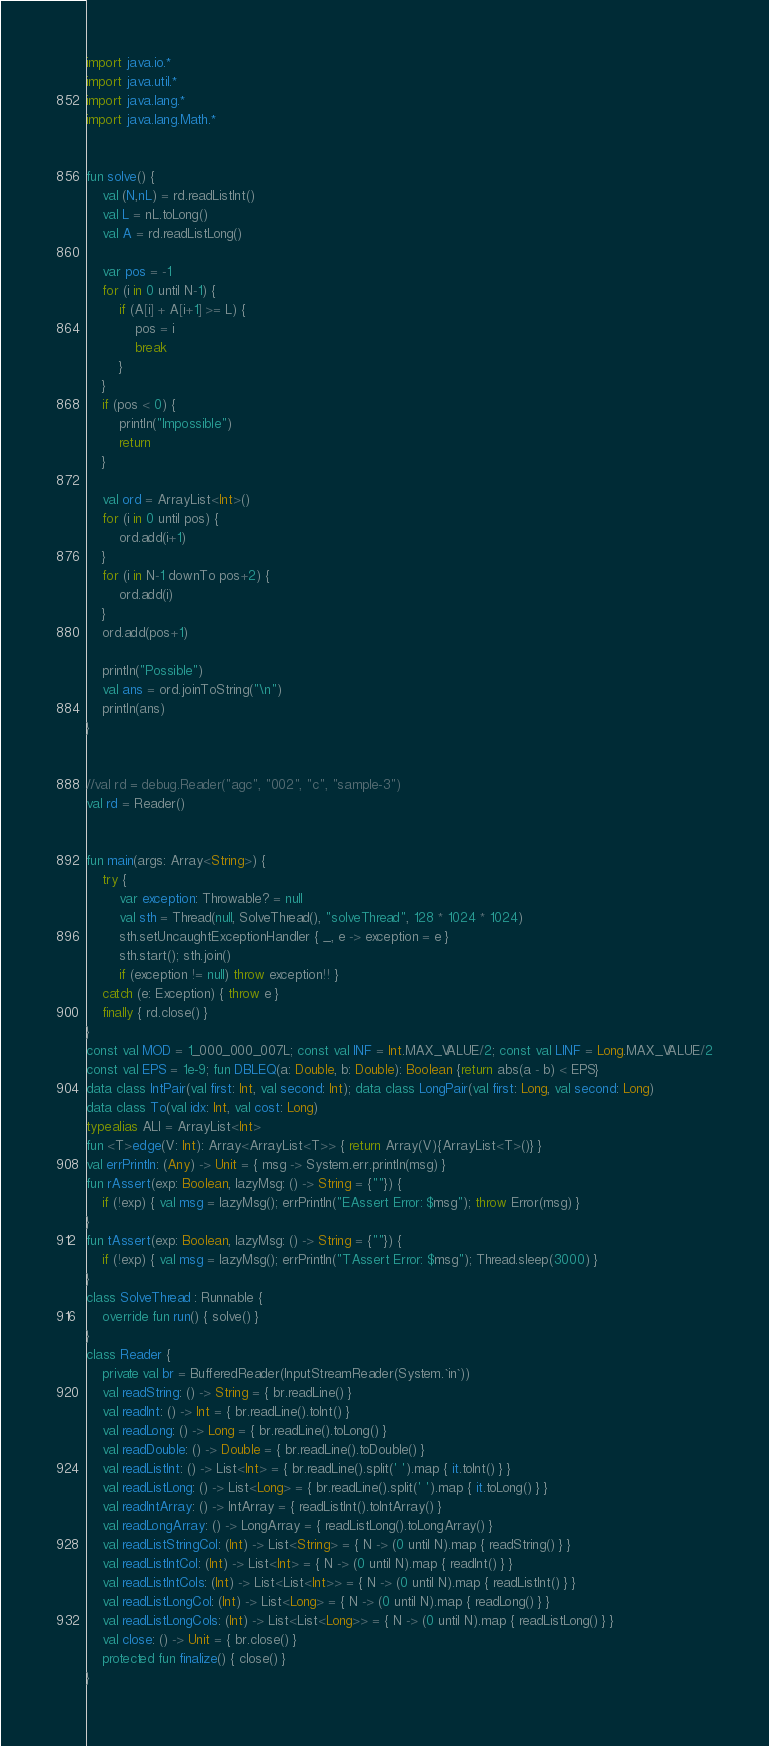Convert code to text. <code><loc_0><loc_0><loc_500><loc_500><_Kotlin_>import java.io.*
import java.util.*
import java.lang.*
import java.lang.Math.*


fun solve() {
    val (N,nL) = rd.readListInt()
    val L = nL.toLong()
    val A = rd.readListLong()

    var pos = -1
    for (i in 0 until N-1) {
        if (A[i] + A[i+1] >= L) {
            pos = i
            break
        }
    }
    if (pos < 0) {
        println("Impossible")
        return
    }

    val ord = ArrayList<Int>()
    for (i in 0 until pos) {
        ord.add(i+1)
    }
    for (i in N-1 downTo pos+2) {
        ord.add(i)
    }
    ord.add(pos+1)

    println("Possible")
    val ans = ord.joinToString("\n")
    println(ans)
}


//val rd = debug.Reader("agc", "002", "c", "sample-3")
val rd = Reader()


fun main(args: Array<String>) {
    try {
        var exception: Throwable? = null
        val sth = Thread(null, SolveThread(), "solveThread", 128 * 1024 * 1024)
        sth.setUncaughtExceptionHandler { _, e -> exception = e }
        sth.start(); sth.join()
        if (exception != null) throw exception!! }
    catch (e: Exception) { throw e }
    finally { rd.close() }
}
const val MOD = 1_000_000_007L; const val INF = Int.MAX_VALUE/2; const val LINF = Long.MAX_VALUE/2
const val EPS = 1e-9; fun DBLEQ(a: Double, b: Double): Boolean {return abs(a - b) < EPS}
data class IntPair(val first: Int, val second: Int); data class LongPair(val first: Long, val second: Long)
data class To(val idx: Int, val cost: Long)
typealias ALI = ArrayList<Int>
fun <T>edge(V: Int): Array<ArrayList<T>> { return Array(V){ArrayList<T>()} }
val errPrintln: (Any) -> Unit = { msg -> System.err.println(msg) }
fun rAssert(exp: Boolean, lazyMsg: () -> String = {""}) {
    if (!exp) { val msg = lazyMsg(); errPrintln("EAssert Error: $msg"); throw Error(msg) }
}
fun tAssert(exp: Boolean, lazyMsg: () -> String = {""}) {
    if (!exp) { val msg = lazyMsg(); errPrintln("TAssert Error: $msg"); Thread.sleep(3000) }
}
class SolveThread : Runnable {
    override fun run() { solve() }
}
class Reader {
    private val br = BufferedReader(InputStreamReader(System.`in`))
    val readString: () -> String = { br.readLine() }
    val readInt: () -> Int = { br.readLine().toInt() }
    val readLong: () -> Long = { br.readLine().toLong() }
    val readDouble: () -> Double = { br.readLine().toDouble() }
    val readListInt: () -> List<Int> = { br.readLine().split(' ').map { it.toInt() } }
    val readListLong: () -> List<Long> = { br.readLine().split(' ').map { it.toLong() } }
    val readIntArray: () -> IntArray = { readListInt().toIntArray() }
    val readLongArray: () -> LongArray = { readListLong().toLongArray() }
    val readListStringCol: (Int) -> List<String> = { N -> (0 until N).map { readString() } }
    val readListIntCol: (Int) -> List<Int> = { N -> (0 until N).map { readInt() } }
    val readListIntCols: (Int) -> List<List<Int>> = { N -> (0 until N).map { readListInt() } }
    val readListLongCol: (Int) -> List<Long> = { N -> (0 until N).map { readLong() } }
    val readListLongCols: (Int) -> List<List<Long>> = { N -> (0 until N).map { readListLong() } }
    val close: () -> Unit = { br.close() }
    protected fun finalize() { close() }
}
</code> 